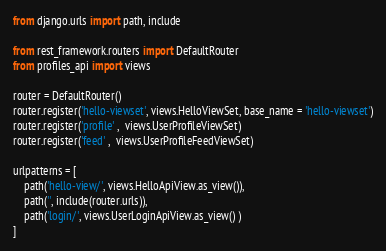Convert code to text. <code><loc_0><loc_0><loc_500><loc_500><_Python_>from django.urls import path, include

from rest_framework.routers import DefaultRouter
from profiles_api import views

router = DefaultRouter()
router.register('hello-viewset', views.HelloViewSet, base_name = 'hello-viewset')
router.register('profile' ,  views.UserProfileViewSet)
router.register('feed' ,  views.UserProfileFeedViewSet)

urlpatterns = [
    path('hello-view/', views.HelloApiView.as_view()),
    path('', include(router.urls)),
    path('login/', views.UserLoginApiView.as_view() )
]
</code> 